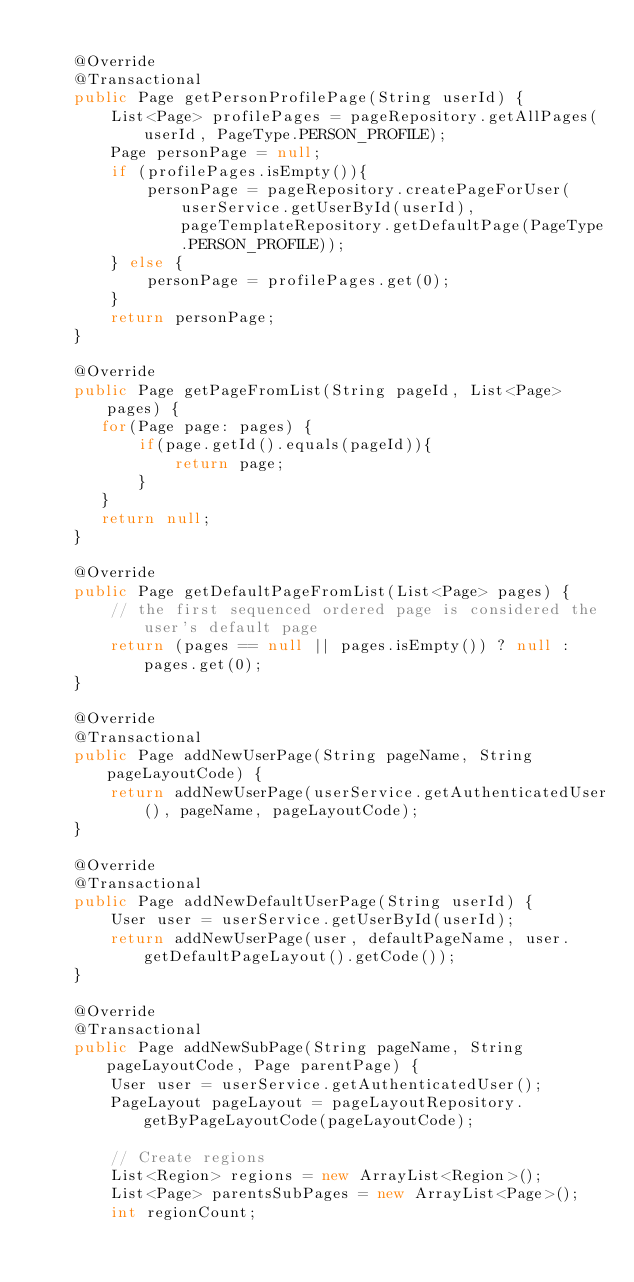Convert code to text. <code><loc_0><loc_0><loc_500><loc_500><_Java_>
    @Override
    @Transactional
    public Page getPersonProfilePage(String userId) {
        List<Page> profilePages = pageRepository.getAllPages(userId, PageType.PERSON_PROFILE);
        Page personPage = null;
        if (profilePages.isEmpty()){
            personPage = pageRepository.createPageForUser(userService.getUserById(userId), pageTemplateRepository.getDefaultPage(PageType.PERSON_PROFILE));
        } else {
            personPage = profilePages.get(0);
        }
        return personPage;
    }

    @Override
    public Page getPageFromList(String pageId, List<Page> pages) {
       for(Page page: pages) {
           if(page.getId().equals(pageId)){
               return page;
           }
       }
       return null;
    }

    @Override
    public Page getDefaultPageFromList(List<Page> pages) {
        // the first sequenced ordered page is considered the user's default page
        return (pages == null || pages.isEmpty()) ? null : pages.get(0);
    }

    @Override
    @Transactional
    public Page addNewUserPage(String pageName, String pageLayoutCode) {
        return addNewUserPage(userService.getAuthenticatedUser(), pageName, pageLayoutCode);
    }

    @Override
    @Transactional
    public Page addNewDefaultUserPage(String userId) {
        User user = userService.getUserById(userId);
        return addNewUserPage(user, defaultPageName, user.getDefaultPageLayout().getCode());
    }

    @Override
    @Transactional
    public Page addNewSubPage(String pageName, String pageLayoutCode, Page parentPage) {
        User user = userService.getAuthenticatedUser();
        PageLayout pageLayout = pageLayoutRepository.getByPageLayoutCode(pageLayoutCode);

        // Create regions
        List<Region> regions = new ArrayList<Region>();
        List<Page> parentsSubPages = new ArrayList<Page>();
        int regionCount;</code> 